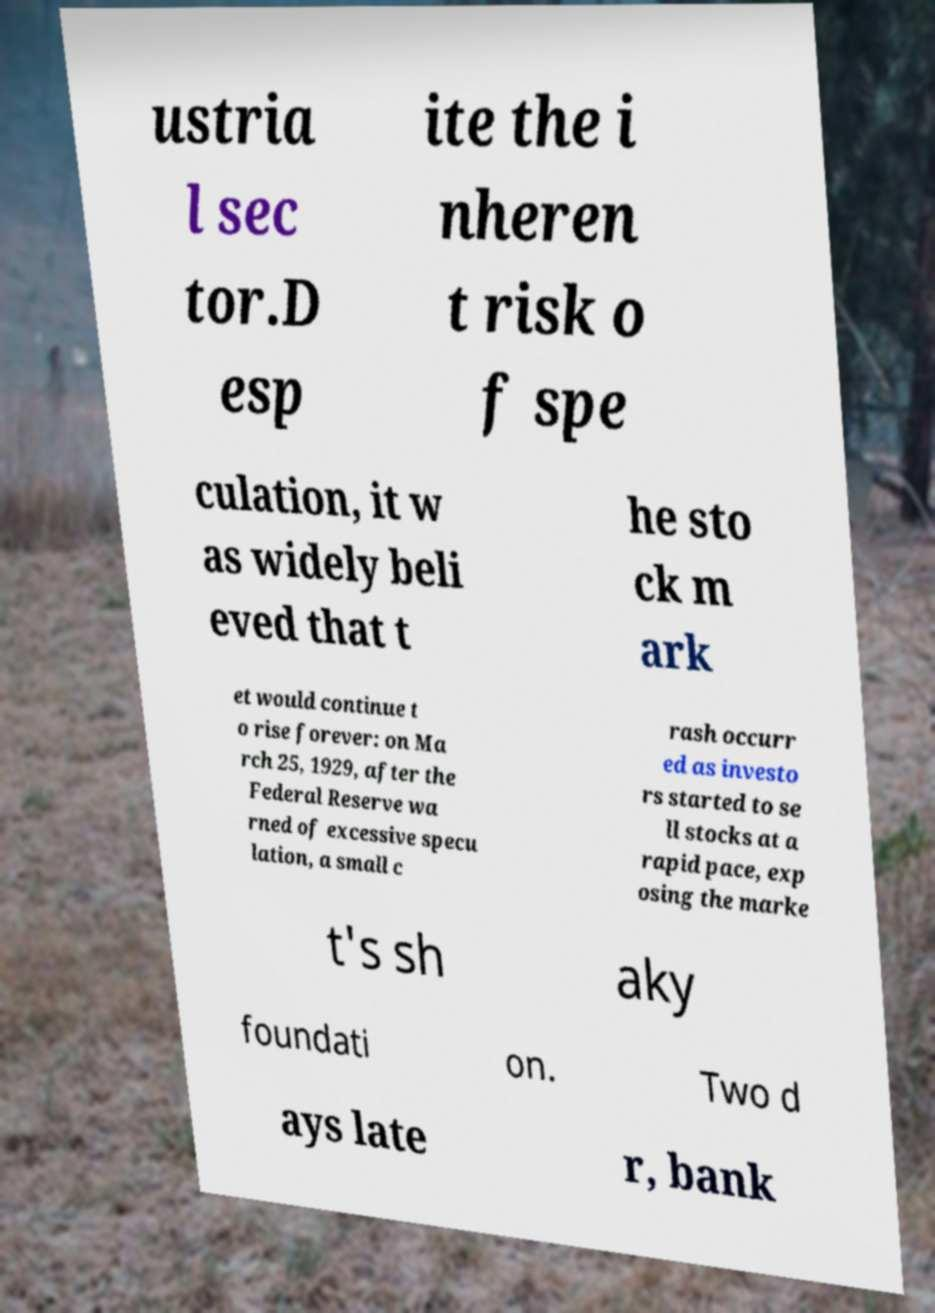Please read and relay the text visible in this image. What does it say? ustria l sec tor.D esp ite the i nheren t risk o f spe culation, it w as widely beli eved that t he sto ck m ark et would continue t o rise forever: on Ma rch 25, 1929, after the Federal Reserve wa rned of excessive specu lation, a small c rash occurr ed as investo rs started to se ll stocks at a rapid pace, exp osing the marke t's sh aky foundati on. Two d ays late r, bank 